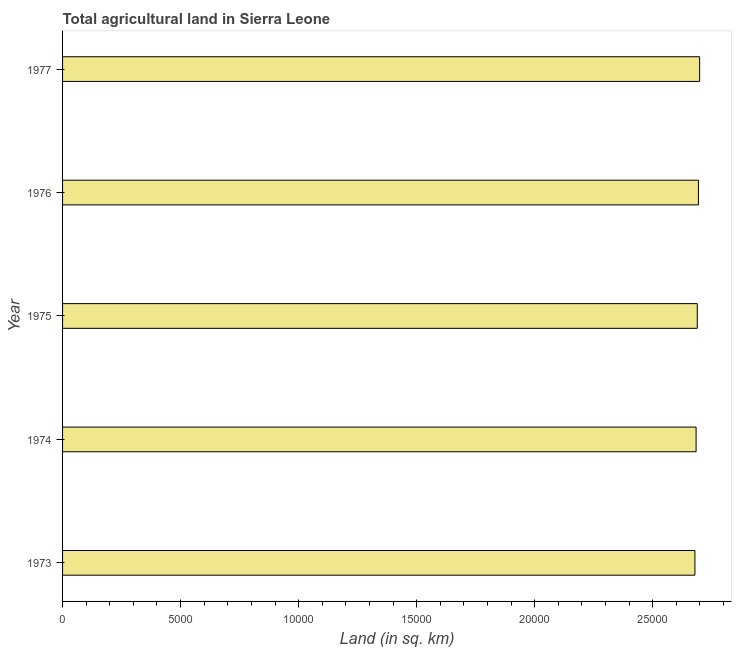What is the title of the graph?
Offer a terse response. Total agricultural land in Sierra Leone. What is the label or title of the X-axis?
Give a very brief answer. Land (in sq. km). What is the label or title of the Y-axis?
Offer a terse response. Year. What is the agricultural land in 1974?
Offer a terse response. 2.68e+04. Across all years, what is the maximum agricultural land?
Your answer should be very brief. 2.70e+04. Across all years, what is the minimum agricultural land?
Your answer should be very brief. 2.68e+04. In which year was the agricultural land maximum?
Provide a succinct answer. 1977. What is the sum of the agricultural land?
Your answer should be very brief. 1.34e+05. What is the difference between the agricultural land in 1973 and 1976?
Your answer should be compact. -150. What is the average agricultural land per year?
Provide a succinct answer. 2.69e+04. What is the median agricultural land?
Provide a succinct answer. 2.69e+04. Do a majority of the years between 1976 and 1975 (inclusive) have agricultural land greater than 13000 sq. km?
Your answer should be compact. No. Is the agricultural land in 1976 less than that in 1977?
Your answer should be compact. Yes. Is the difference between the agricultural land in 1973 and 1976 greater than the difference between any two years?
Ensure brevity in your answer.  No. What is the difference between the highest and the second highest agricultural land?
Offer a terse response. 50. What is the difference between two consecutive major ticks on the X-axis?
Your answer should be compact. 5000. Are the values on the major ticks of X-axis written in scientific E-notation?
Provide a succinct answer. No. What is the Land (in sq. km) in 1973?
Give a very brief answer. 2.68e+04. What is the Land (in sq. km) in 1974?
Give a very brief answer. 2.68e+04. What is the Land (in sq. km) of 1975?
Provide a short and direct response. 2.69e+04. What is the Land (in sq. km) in 1976?
Your answer should be very brief. 2.69e+04. What is the Land (in sq. km) in 1977?
Give a very brief answer. 2.70e+04. What is the difference between the Land (in sq. km) in 1973 and 1975?
Make the answer very short. -100. What is the difference between the Land (in sq. km) in 1973 and 1976?
Give a very brief answer. -150. What is the difference between the Land (in sq. km) in 1973 and 1977?
Your answer should be very brief. -200. What is the difference between the Land (in sq. km) in 1974 and 1976?
Your answer should be compact. -100. What is the difference between the Land (in sq. km) in 1974 and 1977?
Your answer should be very brief. -150. What is the difference between the Land (in sq. km) in 1975 and 1976?
Offer a very short reply. -50. What is the difference between the Land (in sq. km) in 1975 and 1977?
Your answer should be very brief. -100. What is the difference between the Land (in sq. km) in 1976 and 1977?
Keep it short and to the point. -50. What is the ratio of the Land (in sq. km) in 1973 to that in 1976?
Offer a terse response. 0.99. What is the ratio of the Land (in sq. km) in 1974 to that in 1975?
Ensure brevity in your answer.  1. What is the ratio of the Land (in sq. km) in 1974 to that in 1976?
Keep it short and to the point. 1. What is the ratio of the Land (in sq. km) in 1974 to that in 1977?
Your answer should be compact. 0.99. What is the ratio of the Land (in sq. km) in 1975 to that in 1977?
Provide a short and direct response. 1. 